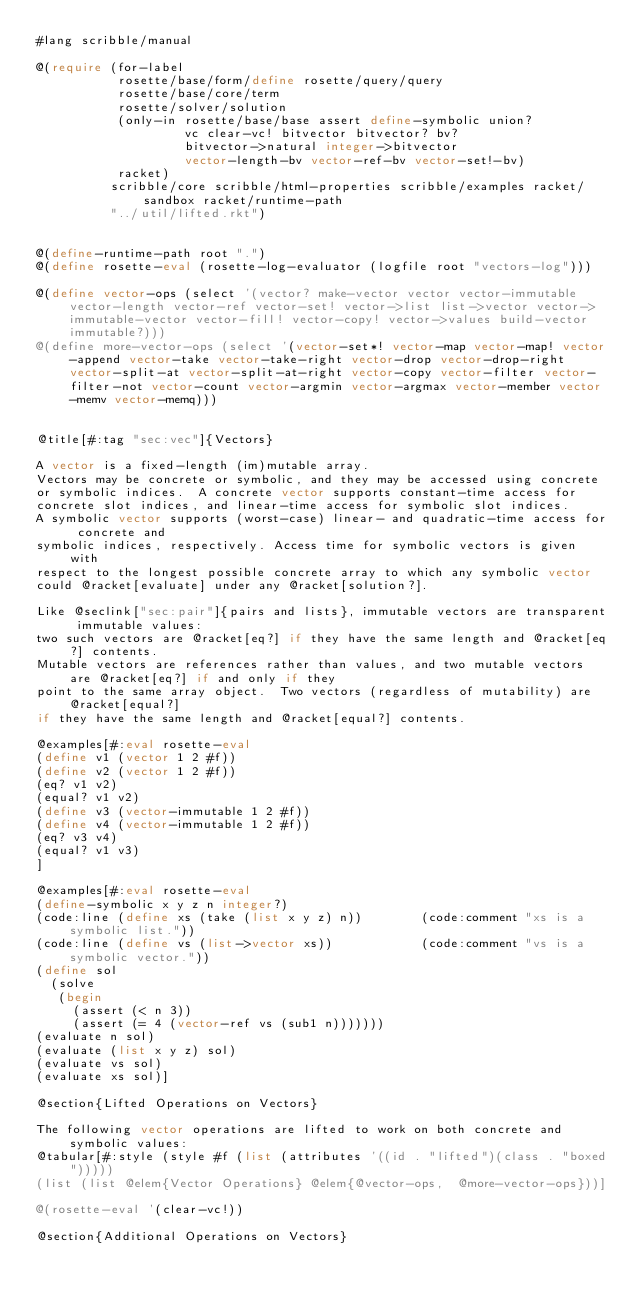Convert code to text. <code><loc_0><loc_0><loc_500><loc_500><_Racket_>#lang scribble/manual

@(require (for-label 
           rosette/base/form/define rosette/query/query 
           rosette/base/core/term
           rosette/solver/solution
           (only-in rosette/base/base assert define-symbolic union?
                    vc clear-vc! bitvector bitvector? bv?
                    bitvector->natural integer->bitvector
                    vector-length-bv vector-ref-bv vector-set!-bv) 
           racket)
          scribble/core scribble/html-properties scribble/examples racket/sandbox racket/runtime-path
          "../util/lifted.rkt")


@(define-runtime-path root ".")
@(define rosette-eval (rosette-log-evaluator (logfile root "vectors-log")))

@(define vector-ops (select '(vector? make-vector vector vector-immutable vector-length vector-ref vector-set! vector->list list->vector vector->immutable-vector vector-fill! vector-copy! vector->values build-vector immutable?)))
@(define more-vector-ops (select '(vector-set*! vector-map vector-map! vector-append vector-take vector-take-right vector-drop vector-drop-right vector-split-at vector-split-at-right vector-copy vector-filter vector-filter-not vector-count vector-argmin vector-argmax vector-member vector-memv vector-memq)))


@title[#:tag "sec:vec"]{Vectors}

A vector is a fixed-length (im)mutable array. 
Vectors may be concrete or symbolic, and they may be accessed using concrete 
or symbolic indices.  A concrete vector supports constant-time access for 
concrete slot indices, and linear-time access for symbolic slot indices.  
A symbolic vector supports (worst-case) linear- and quadratic-time access for concrete and 
symbolic indices, respectively. Access time for symbolic vectors is given with 
respect to the longest possible concrete array to which any symbolic vector 
could @racket[evaluate] under any @racket[solution?]. 

Like @seclink["sec:pair"]{pairs and lists}, immutable vectors are transparent immutable values:
two such vectors are @racket[eq?] if they have the same length and @racket[eq?] contents.
Mutable vectors are references rather than values, and two mutable vectors are @racket[eq?] if and only if they 
point to the same array object.  Two vectors (regardless of mutability) are @racket[equal?] 
if they have the same length and @racket[equal?] contents.

@examples[#:eval rosette-eval
(define v1 (vector 1 2 #f))
(define v2 (vector 1 2 #f))
(eq? v1 v2)
(equal? v1 v2)
(define v3 (vector-immutable 1 2 #f))
(define v4 (vector-immutable 1 2 #f))
(eq? v3 v4)
(equal? v1 v3)
]

@examples[#:eval rosette-eval
(define-symbolic x y z n integer?)
(code:line (define xs (take (list x y z) n))        (code:comment "xs is a symbolic list."))
(code:line (define vs (list->vector xs))            (code:comment "vs is a symbolic vector."))
(define sol
  (solve
   (begin
     (assert (< n 3))
     (assert (= 4 (vector-ref vs (sub1 n)))))))
(evaluate n sol)
(evaluate (list x y z) sol)
(evaluate vs sol)
(evaluate xs sol)]

@section{Lifted Operations on Vectors}

The following vector operations are lifted to work on both concrete and symbolic values:
@tabular[#:style (style #f (list (attributes '((id . "lifted")(class . "boxed")))))
(list (list @elem{Vector Operations} @elem{@vector-ops,  @more-vector-ops}))]

@(rosette-eval '(clear-vc!))

@section{Additional Operations on Vectors}
</code> 